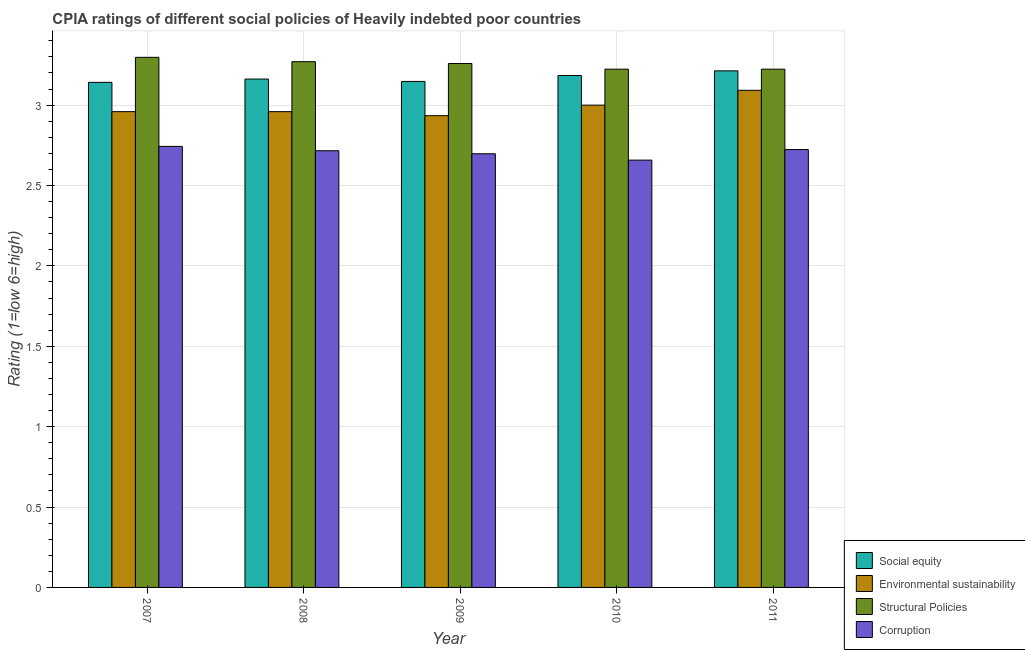Are the number of bars per tick equal to the number of legend labels?
Ensure brevity in your answer.  Yes. Are the number of bars on each tick of the X-axis equal?
Give a very brief answer. Yes. How many bars are there on the 1st tick from the right?
Offer a very short reply. 4. What is the cpia rating of corruption in 2008?
Ensure brevity in your answer.  2.72. Across all years, what is the maximum cpia rating of corruption?
Offer a terse response. 2.74. Across all years, what is the minimum cpia rating of social equity?
Provide a short and direct response. 3.14. In which year was the cpia rating of corruption maximum?
Your answer should be very brief. 2007. In which year was the cpia rating of corruption minimum?
Provide a succinct answer. 2010. What is the total cpia rating of structural policies in the graph?
Provide a succinct answer. 16.27. What is the difference between the cpia rating of environmental sustainability in 2007 and that in 2011?
Your answer should be compact. -0.13. What is the difference between the cpia rating of social equity in 2010 and the cpia rating of corruption in 2011?
Provide a short and direct response. -0.03. What is the average cpia rating of social equity per year?
Give a very brief answer. 3.17. In the year 2007, what is the difference between the cpia rating of social equity and cpia rating of structural policies?
Ensure brevity in your answer.  0. In how many years, is the cpia rating of environmental sustainability greater than 0.6?
Provide a short and direct response. 5. What is the ratio of the cpia rating of corruption in 2009 to that in 2010?
Your answer should be compact. 1.01. Is the cpia rating of environmental sustainability in 2007 less than that in 2009?
Ensure brevity in your answer.  No. Is the difference between the cpia rating of environmental sustainability in 2007 and 2011 greater than the difference between the cpia rating of corruption in 2007 and 2011?
Offer a terse response. No. What is the difference between the highest and the second highest cpia rating of environmental sustainability?
Make the answer very short. 0.09. What is the difference between the highest and the lowest cpia rating of structural policies?
Offer a terse response. 0.07. In how many years, is the cpia rating of structural policies greater than the average cpia rating of structural policies taken over all years?
Your answer should be compact. 3. Is the sum of the cpia rating of corruption in 2007 and 2010 greater than the maximum cpia rating of environmental sustainability across all years?
Provide a short and direct response. Yes. What does the 2nd bar from the left in 2008 represents?
Ensure brevity in your answer.  Environmental sustainability. What does the 3rd bar from the right in 2007 represents?
Keep it short and to the point. Environmental sustainability. Is it the case that in every year, the sum of the cpia rating of social equity and cpia rating of environmental sustainability is greater than the cpia rating of structural policies?
Make the answer very short. Yes. How many bars are there?
Keep it short and to the point. 20. What is the difference between two consecutive major ticks on the Y-axis?
Your answer should be very brief. 0.5. Are the values on the major ticks of Y-axis written in scientific E-notation?
Offer a very short reply. No. Does the graph contain any zero values?
Ensure brevity in your answer.  No. Does the graph contain grids?
Offer a terse response. Yes. How many legend labels are there?
Offer a very short reply. 4. What is the title of the graph?
Provide a short and direct response. CPIA ratings of different social policies of Heavily indebted poor countries. Does "Public sector management" appear as one of the legend labels in the graph?
Ensure brevity in your answer.  No. What is the label or title of the Y-axis?
Your answer should be very brief. Rating (1=low 6=high). What is the Rating (1=low 6=high) of Social equity in 2007?
Ensure brevity in your answer.  3.14. What is the Rating (1=low 6=high) in Environmental sustainability in 2007?
Give a very brief answer. 2.96. What is the Rating (1=low 6=high) in Structural Policies in 2007?
Keep it short and to the point. 3.3. What is the Rating (1=low 6=high) in Corruption in 2007?
Give a very brief answer. 2.74. What is the Rating (1=low 6=high) of Social equity in 2008?
Give a very brief answer. 3.16. What is the Rating (1=low 6=high) in Environmental sustainability in 2008?
Your answer should be compact. 2.96. What is the Rating (1=low 6=high) of Structural Policies in 2008?
Provide a succinct answer. 3.27. What is the Rating (1=low 6=high) in Corruption in 2008?
Make the answer very short. 2.72. What is the Rating (1=low 6=high) in Social equity in 2009?
Provide a short and direct response. 3.15. What is the Rating (1=low 6=high) of Environmental sustainability in 2009?
Your response must be concise. 2.93. What is the Rating (1=low 6=high) of Structural Policies in 2009?
Provide a short and direct response. 3.26. What is the Rating (1=low 6=high) of Corruption in 2009?
Your response must be concise. 2.7. What is the Rating (1=low 6=high) of Social equity in 2010?
Make the answer very short. 3.18. What is the Rating (1=low 6=high) in Environmental sustainability in 2010?
Offer a very short reply. 3. What is the Rating (1=low 6=high) in Structural Policies in 2010?
Offer a very short reply. 3.22. What is the Rating (1=low 6=high) of Corruption in 2010?
Ensure brevity in your answer.  2.66. What is the Rating (1=low 6=high) of Social equity in 2011?
Make the answer very short. 3.21. What is the Rating (1=low 6=high) in Environmental sustainability in 2011?
Give a very brief answer. 3.09. What is the Rating (1=low 6=high) in Structural Policies in 2011?
Your answer should be very brief. 3.22. What is the Rating (1=low 6=high) of Corruption in 2011?
Offer a very short reply. 2.72. Across all years, what is the maximum Rating (1=low 6=high) in Social equity?
Keep it short and to the point. 3.21. Across all years, what is the maximum Rating (1=low 6=high) in Environmental sustainability?
Make the answer very short. 3.09. Across all years, what is the maximum Rating (1=low 6=high) in Structural Policies?
Make the answer very short. 3.3. Across all years, what is the maximum Rating (1=low 6=high) in Corruption?
Give a very brief answer. 2.74. Across all years, what is the minimum Rating (1=low 6=high) of Social equity?
Offer a very short reply. 3.14. Across all years, what is the minimum Rating (1=low 6=high) in Environmental sustainability?
Provide a succinct answer. 2.93. Across all years, what is the minimum Rating (1=low 6=high) of Structural Policies?
Keep it short and to the point. 3.22. Across all years, what is the minimum Rating (1=low 6=high) in Corruption?
Offer a terse response. 2.66. What is the total Rating (1=low 6=high) in Social equity in the graph?
Give a very brief answer. 15.85. What is the total Rating (1=low 6=high) of Environmental sustainability in the graph?
Offer a very short reply. 14.95. What is the total Rating (1=low 6=high) in Structural Policies in the graph?
Keep it short and to the point. 16.27. What is the total Rating (1=low 6=high) of Corruption in the graph?
Make the answer very short. 13.54. What is the difference between the Rating (1=low 6=high) in Social equity in 2007 and that in 2008?
Provide a succinct answer. -0.02. What is the difference between the Rating (1=low 6=high) in Environmental sustainability in 2007 and that in 2008?
Your answer should be compact. 0. What is the difference between the Rating (1=low 6=high) of Structural Policies in 2007 and that in 2008?
Your answer should be compact. 0.03. What is the difference between the Rating (1=low 6=high) in Corruption in 2007 and that in 2008?
Provide a succinct answer. 0.03. What is the difference between the Rating (1=low 6=high) in Social equity in 2007 and that in 2009?
Your answer should be very brief. -0.01. What is the difference between the Rating (1=low 6=high) in Environmental sustainability in 2007 and that in 2009?
Keep it short and to the point. 0.03. What is the difference between the Rating (1=low 6=high) in Structural Policies in 2007 and that in 2009?
Give a very brief answer. 0.04. What is the difference between the Rating (1=low 6=high) in Corruption in 2007 and that in 2009?
Your answer should be very brief. 0.05. What is the difference between the Rating (1=low 6=high) of Social equity in 2007 and that in 2010?
Provide a succinct answer. -0.04. What is the difference between the Rating (1=low 6=high) of Environmental sustainability in 2007 and that in 2010?
Keep it short and to the point. -0.04. What is the difference between the Rating (1=low 6=high) of Structural Policies in 2007 and that in 2010?
Your answer should be very brief. 0.07. What is the difference between the Rating (1=low 6=high) in Corruption in 2007 and that in 2010?
Give a very brief answer. 0.09. What is the difference between the Rating (1=low 6=high) of Social equity in 2007 and that in 2011?
Your response must be concise. -0.07. What is the difference between the Rating (1=low 6=high) in Environmental sustainability in 2007 and that in 2011?
Make the answer very short. -0.13. What is the difference between the Rating (1=low 6=high) of Structural Policies in 2007 and that in 2011?
Offer a terse response. 0.07. What is the difference between the Rating (1=low 6=high) of Corruption in 2007 and that in 2011?
Offer a very short reply. 0.02. What is the difference between the Rating (1=low 6=high) in Social equity in 2008 and that in 2009?
Offer a very short reply. 0.01. What is the difference between the Rating (1=low 6=high) of Environmental sustainability in 2008 and that in 2009?
Keep it short and to the point. 0.03. What is the difference between the Rating (1=low 6=high) of Structural Policies in 2008 and that in 2009?
Provide a short and direct response. 0.01. What is the difference between the Rating (1=low 6=high) in Corruption in 2008 and that in 2009?
Ensure brevity in your answer.  0.02. What is the difference between the Rating (1=low 6=high) in Social equity in 2008 and that in 2010?
Your answer should be very brief. -0.02. What is the difference between the Rating (1=low 6=high) of Environmental sustainability in 2008 and that in 2010?
Keep it short and to the point. -0.04. What is the difference between the Rating (1=low 6=high) of Structural Policies in 2008 and that in 2010?
Provide a succinct answer. 0.05. What is the difference between the Rating (1=low 6=high) of Corruption in 2008 and that in 2010?
Provide a succinct answer. 0.06. What is the difference between the Rating (1=low 6=high) of Social equity in 2008 and that in 2011?
Your answer should be compact. -0.05. What is the difference between the Rating (1=low 6=high) in Environmental sustainability in 2008 and that in 2011?
Your answer should be compact. -0.13. What is the difference between the Rating (1=low 6=high) in Structural Policies in 2008 and that in 2011?
Provide a succinct answer. 0.05. What is the difference between the Rating (1=low 6=high) of Corruption in 2008 and that in 2011?
Keep it short and to the point. -0.01. What is the difference between the Rating (1=low 6=high) in Social equity in 2009 and that in 2010?
Ensure brevity in your answer.  -0.04. What is the difference between the Rating (1=low 6=high) in Environmental sustainability in 2009 and that in 2010?
Make the answer very short. -0.07. What is the difference between the Rating (1=low 6=high) of Structural Policies in 2009 and that in 2010?
Offer a very short reply. 0.04. What is the difference between the Rating (1=low 6=high) in Corruption in 2009 and that in 2010?
Your answer should be compact. 0.04. What is the difference between the Rating (1=low 6=high) in Social equity in 2009 and that in 2011?
Provide a succinct answer. -0.07. What is the difference between the Rating (1=low 6=high) in Environmental sustainability in 2009 and that in 2011?
Your response must be concise. -0.16. What is the difference between the Rating (1=low 6=high) of Structural Policies in 2009 and that in 2011?
Offer a very short reply. 0.04. What is the difference between the Rating (1=low 6=high) of Corruption in 2009 and that in 2011?
Keep it short and to the point. -0.03. What is the difference between the Rating (1=low 6=high) of Social equity in 2010 and that in 2011?
Your response must be concise. -0.03. What is the difference between the Rating (1=low 6=high) of Environmental sustainability in 2010 and that in 2011?
Provide a succinct answer. -0.09. What is the difference between the Rating (1=low 6=high) in Corruption in 2010 and that in 2011?
Provide a short and direct response. -0.07. What is the difference between the Rating (1=low 6=high) of Social equity in 2007 and the Rating (1=low 6=high) of Environmental sustainability in 2008?
Give a very brief answer. 0.18. What is the difference between the Rating (1=low 6=high) in Social equity in 2007 and the Rating (1=low 6=high) in Structural Policies in 2008?
Ensure brevity in your answer.  -0.13. What is the difference between the Rating (1=low 6=high) of Social equity in 2007 and the Rating (1=low 6=high) of Corruption in 2008?
Provide a succinct answer. 0.43. What is the difference between the Rating (1=low 6=high) of Environmental sustainability in 2007 and the Rating (1=low 6=high) of Structural Policies in 2008?
Your answer should be very brief. -0.31. What is the difference between the Rating (1=low 6=high) in Environmental sustainability in 2007 and the Rating (1=low 6=high) in Corruption in 2008?
Your answer should be very brief. 0.24. What is the difference between the Rating (1=low 6=high) of Structural Policies in 2007 and the Rating (1=low 6=high) of Corruption in 2008?
Keep it short and to the point. 0.58. What is the difference between the Rating (1=low 6=high) in Social equity in 2007 and the Rating (1=low 6=high) in Environmental sustainability in 2009?
Offer a very short reply. 0.21. What is the difference between the Rating (1=low 6=high) in Social equity in 2007 and the Rating (1=low 6=high) in Structural Policies in 2009?
Give a very brief answer. -0.12. What is the difference between the Rating (1=low 6=high) in Social equity in 2007 and the Rating (1=low 6=high) in Corruption in 2009?
Your response must be concise. 0.44. What is the difference between the Rating (1=low 6=high) of Environmental sustainability in 2007 and the Rating (1=low 6=high) of Structural Policies in 2009?
Make the answer very short. -0.3. What is the difference between the Rating (1=low 6=high) of Environmental sustainability in 2007 and the Rating (1=low 6=high) of Corruption in 2009?
Provide a short and direct response. 0.26. What is the difference between the Rating (1=low 6=high) of Structural Policies in 2007 and the Rating (1=low 6=high) of Corruption in 2009?
Give a very brief answer. 0.6. What is the difference between the Rating (1=low 6=high) in Social equity in 2007 and the Rating (1=low 6=high) in Environmental sustainability in 2010?
Ensure brevity in your answer.  0.14. What is the difference between the Rating (1=low 6=high) in Social equity in 2007 and the Rating (1=low 6=high) in Structural Policies in 2010?
Make the answer very short. -0.08. What is the difference between the Rating (1=low 6=high) in Social equity in 2007 and the Rating (1=low 6=high) in Corruption in 2010?
Keep it short and to the point. 0.48. What is the difference between the Rating (1=low 6=high) of Environmental sustainability in 2007 and the Rating (1=low 6=high) of Structural Policies in 2010?
Ensure brevity in your answer.  -0.26. What is the difference between the Rating (1=low 6=high) in Environmental sustainability in 2007 and the Rating (1=low 6=high) in Corruption in 2010?
Your response must be concise. 0.3. What is the difference between the Rating (1=low 6=high) of Structural Policies in 2007 and the Rating (1=low 6=high) of Corruption in 2010?
Ensure brevity in your answer.  0.64. What is the difference between the Rating (1=low 6=high) of Social equity in 2007 and the Rating (1=low 6=high) of Environmental sustainability in 2011?
Provide a short and direct response. 0.05. What is the difference between the Rating (1=low 6=high) in Social equity in 2007 and the Rating (1=low 6=high) in Structural Policies in 2011?
Provide a succinct answer. -0.08. What is the difference between the Rating (1=low 6=high) in Social equity in 2007 and the Rating (1=low 6=high) in Corruption in 2011?
Provide a short and direct response. 0.42. What is the difference between the Rating (1=low 6=high) in Environmental sustainability in 2007 and the Rating (1=low 6=high) in Structural Policies in 2011?
Give a very brief answer. -0.26. What is the difference between the Rating (1=low 6=high) of Environmental sustainability in 2007 and the Rating (1=low 6=high) of Corruption in 2011?
Your answer should be compact. 0.24. What is the difference between the Rating (1=low 6=high) in Structural Policies in 2007 and the Rating (1=low 6=high) in Corruption in 2011?
Keep it short and to the point. 0.57. What is the difference between the Rating (1=low 6=high) of Social equity in 2008 and the Rating (1=low 6=high) of Environmental sustainability in 2009?
Make the answer very short. 0.23. What is the difference between the Rating (1=low 6=high) of Social equity in 2008 and the Rating (1=low 6=high) of Structural Policies in 2009?
Offer a terse response. -0.1. What is the difference between the Rating (1=low 6=high) in Social equity in 2008 and the Rating (1=low 6=high) in Corruption in 2009?
Make the answer very short. 0.46. What is the difference between the Rating (1=low 6=high) of Environmental sustainability in 2008 and the Rating (1=low 6=high) of Structural Policies in 2009?
Offer a terse response. -0.3. What is the difference between the Rating (1=low 6=high) in Environmental sustainability in 2008 and the Rating (1=low 6=high) in Corruption in 2009?
Provide a short and direct response. 0.26. What is the difference between the Rating (1=low 6=high) of Structural Policies in 2008 and the Rating (1=low 6=high) of Corruption in 2009?
Make the answer very short. 0.57. What is the difference between the Rating (1=low 6=high) of Social equity in 2008 and the Rating (1=low 6=high) of Environmental sustainability in 2010?
Provide a short and direct response. 0.16. What is the difference between the Rating (1=low 6=high) in Social equity in 2008 and the Rating (1=low 6=high) in Structural Policies in 2010?
Offer a very short reply. -0.06. What is the difference between the Rating (1=low 6=high) of Social equity in 2008 and the Rating (1=low 6=high) of Corruption in 2010?
Offer a very short reply. 0.5. What is the difference between the Rating (1=low 6=high) in Environmental sustainability in 2008 and the Rating (1=low 6=high) in Structural Policies in 2010?
Your response must be concise. -0.26. What is the difference between the Rating (1=low 6=high) of Environmental sustainability in 2008 and the Rating (1=low 6=high) of Corruption in 2010?
Your response must be concise. 0.3. What is the difference between the Rating (1=low 6=high) in Structural Policies in 2008 and the Rating (1=low 6=high) in Corruption in 2010?
Offer a terse response. 0.61. What is the difference between the Rating (1=low 6=high) of Social equity in 2008 and the Rating (1=low 6=high) of Environmental sustainability in 2011?
Make the answer very short. 0.07. What is the difference between the Rating (1=low 6=high) of Social equity in 2008 and the Rating (1=low 6=high) of Structural Policies in 2011?
Make the answer very short. -0.06. What is the difference between the Rating (1=low 6=high) of Social equity in 2008 and the Rating (1=low 6=high) of Corruption in 2011?
Provide a succinct answer. 0.44. What is the difference between the Rating (1=low 6=high) of Environmental sustainability in 2008 and the Rating (1=low 6=high) of Structural Policies in 2011?
Keep it short and to the point. -0.26. What is the difference between the Rating (1=low 6=high) of Environmental sustainability in 2008 and the Rating (1=low 6=high) of Corruption in 2011?
Keep it short and to the point. 0.24. What is the difference between the Rating (1=low 6=high) in Structural Policies in 2008 and the Rating (1=low 6=high) in Corruption in 2011?
Keep it short and to the point. 0.55. What is the difference between the Rating (1=low 6=high) in Social equity in 2009 and the Rating (1=low 6=high) in Environmental sustainability in 2010?
Your response must be concise. 0.15. What is the difference between the Rating (1=low 6=high) of Social equity in 2009 and the Rating (1=low 6=high) of Structural Policies in 2010?
Offer a very short reply. -0.08. What is the difference between the Rating (1=low 6=high) in Social equity in 2009 and the Rating (1=low 6=high) in Corruption in 2010?
Provide a short and direct response. 0.49. What is the difference between the Rating (1=low 6=high) in Environmental sustainability in 2009 and the Rating (1=low 6=high) in Structural Policies in 2010?
Keep it short and to the point. -0.29. What is the difference between the Rating (1=low 6=high) of Environmental sustainability in 2009 and the Rating (1=low 6=high) of Corruption in 2010?
Make the answer very short. 0.28. What is the difference between the Rating (1=low 6=high) of Structural Policies in 2009 and the Rating (1=low 6=high) of Corruption in 2010?
Your answer should be very brief. 0.6. What is the difference between the Rating (1=low 6=high) of Social equity in 2009 and the Rating (1=low 6=high) of Environmental sustainability in 2011?
Offer a very short reply. 0.06. What is the difference between the Rating (1=low 6=high) of Social equity in 2009 and the Rating (1=low 6=high) of Structural Policies in 2011?
Make the answer very short. -0.08. What is the difference between the Rating (1=low 6=high) of Social equity in 2009 and the Rating (1=low 6=high) of Corruption in 2011?
Offer a terse response. 0.42. What is the difference between the Rating (1=low 6=high) in Environmental sustainability in 2009 and the Rating (1=low 6=high) in Structural Policies in 2011?
Offer a terse response. -0.29. What is the difference between the Rating (1=low 6=high) of Environmental sustainability in 2009 and the Rating (1=low 6=high) of Corruption in 2011?
Your answer should be very brief. 0.21. What is the difference between the Rating (1=low 6=high) of Structural Policies in 2009 and the Rating (1=low 6=high) of Corruption in 2011?
Keep it short and to the point. 0.54. What is the difference between the Rating (1=low 6=high) in Social equity in 2010 and the Rating (1=low 6=high) in Environmental sustainability in 2011?
Your answer should be compact. 0.09. What is the difference between the Rating (1=low 6=high) of Social equity in 2010 and the Rating (1=low 6=high) of Structural Policies in 2011?
Keep it short and to the point. -0.04. What is the difference between the Rating (1=low 6=high) in Social equity in 2010 and the Rating (1=low 6=high) in Corruption in 2011?
Offer a very short reply. 0.46. What is the difference between the Rating (1=low 6=high) of Environmental sustainability in 2010 and the Rating (1=low 6=high) of Structural Policies in 2011?
Give a very brief answer. -0.22. What is the difference between the Rating (1=low 6=high) in Environmental sustainability in 2010 and the Rating (1=low 6=high) in Corruption in 2011?
Make the answer very short. 0.28. What is the difference between the Rating (1=low 6=high) of Structural Policies in 2010 and the Rating (1=low 6=high) of Corruption in 2011?
Provide a succinct answer. 0.5. What is the average Rating (1=low 6=high) of Social equity per year?
Offer a very short reply. 3.17. What is the average Rating (1=low 6=high) of Environmental sustainability per year?
Keep it short and to the point. 2.99. What is the average Rating (1=low 6=high) of Structural Policies per year?
Keep it short and to the point. 3.25. What is the average Rating (1=low 6=high) of Corruption per year?
Keep it short and to the point. 2.71. In the year 2007, what is the difference between the Rating (1=low 6=high) in Social equity and Rating (1=low 6=high) in Environmental sustainability?
Make the answer very short. 0.18. In the year 2007, what is the difference between the Rating (1=low 6=high) in Social equity and Rating (1=low 6=high) in Structural Policies?
Your response must be concise. -0.16. In the year 2007, what is the difference between the Rating (1=low 6=high) in Social equity and Rating (1=low 6=high) in Corruption?
Your response must be concise. 0.4. In the year 2007, what is the difference between the Rating (1=low 6=high) of Environmental sustainability and Rating (1=low 6=high) of Structural Policies?
Your answer should be compact. -0.34. In the year 2007, what is the difference between the Rating (1=low 6=high) in Environmental sustainability and Rating (1=low 6=high) in Corruption?
Keep it short and to the point. 0.22. In the year 2007, what is the difference between the Rating (1=low 6=high) of Structural Policies and Rating (1=low 6=high) of Corruption?
Offer a very short reply. 0.55. In the year 2008, what is the difference between the Rating (1=low 6=high) in Social equity and Rating (1=low 6=high) in Environmental sustainability?
Give a very brief answer. 0.2. In the year 2008, what is the difference between the Rating (1=low 6=high) of Social equity and Rating (1=low 6=high) of Structural Policies?
Ensure brevity in your answer.  -0.11. In the year 2008, what is the difference between the Rating (1=low 6=high) in Social equity and Rating (1=low 6=high) in Corruption?
Give a very brief answer. 0.45. In the year 2008, what is the difference between the Rating (1=low 6=high) of Environmental sustainability and Rating (1=low 6=high) of Structural Policies?
Your answer should be very brief. -0.31. In the year 2008, what is the difference between the Rating (1=low 6=high) in Environmental sustainability and Rating (1=low 6=high) in Corruption?
Your answer should be very brief. 0.24. In the year 2008, what is the difference between the Rating (1=low 6=high) of Structural Policies and Rating (1=low 6=high) of Corruption?
Offer a very short reply. 0.55. In the year 2009, what is the difference between the Rating (1=low 6=high) of Social equity and Rating (1=low 6=high) of Environmental sustainability?
Give a very brief answer. 0.21. In the year 2009, what is the difference between the Rating (1=low 6=high) of Social equity and Rating (1=low 6=high) of Structural Policies?
Offer a very short reply. -0.11. In the year 2009, what is the difference between the Rating (1=low 6=high) in Social equity and Rating (1=low 6=high) in Corruption?
Keep it short and to the point. 0.45. In the year 2009, what is the difference between the Rating (1=low 6=high) in Environmental sustainability and Rating (1=low 6=high) in Structural Policies?
Give a very brief answer. -0.32. In the year 2009, what is the difference between the Rating (1=low 6=high) in Environmental sustainability and Rating (1=low 6=high) in Corruption?
Your answer should be compact. 0.24. In the year 2009, what is the difference between the Rating (1=low 6=high) in Structural Policies and Rating (1=low 6=high) in Corruption?
Keep it short and to the point. 0.56. In the year 2010, what is the difference between the Rating (1=low 6=high) of Social equity and Rating (1=low 6=high) of Environmental sustainability?
Ensure brevity in your answer.  0.18. In the year 2010, what is the difference between the Rating (1=low 6=high) in Social equity and Rating (1=low 6=high) in Structural Policies?
Ensure brevity in your answer.  -0.04. In the year 2010, what is the difference between the Rating (1=low 6=high) of Social equity and Rating (1=low 6=high) of Corruption?
Offer a very short reply. 0.53. In the year 2010, what is the difference between the Rating (1=low 6=high) in Environmental sustainability and Rating (1=low 6=high) in Structural Policies?
Give a very brief answer. -0.22. In the year 2010, what is the difference between the Rating (1=low 6=high) in Environmental sustainability and Rating (1=low 6=high) in Corruption?
Provide a succinct answer. 0.34. In the year 2010, what is the difference between the Rating (1=low 6=high) in Structural Policies and Rating (1=low 6=high) in Corruption?
Keep it short and to the point. 0.57. In the year 2011, what is the difference between the Rating (1=low 6=high) of Social equity and Rating (1=low 6=high) of Environmental sustainability?
Provide a short and direct response. 0.12. In the year 2011, what is the difference between the Rating (1=low 6=high) in Social equity and Rating (1=low 6=high) in Structural Policies?
Provide a succinct answer. -0.01. In the year 2011, what is the difference between the Rating (1=low 6=high) of Social equity and Rating (1=low 6=high) of Corruption?
Keep it short and to the point. 0.49. In the year 2011, what is the difference between the Rating (1=low 6=high) in Environmental sustainability and Rating (1=low 6=high) in Structural Policies?
Offer a very short reply. -0.13. In the year 2011, what is the difference between the Rating (1=low 6=high) in Environmental sustainability and Rating (1=low 6=high) in Corruption?
Your response must be concise. 0.37. In the year 2011, what is the difference between the Rating (1=low 6=high) in Structural Policies and Rating (1=low 6=high) in Corruption?
Ensure brevity in your answer.  0.5. What is the ratio of the Rating (1=low 6=high) of Social equity in 2007 to that in 2008?
Ensure brevity in your answer.  0.99. What is the ratio of the Rating (1=low 6=high) in Structural Policies in 2007 to that in 2008?
Provide a short and direct response. 1.01. What is the ratio of the Rating (1=low 6=high) in Corruption in 2007 to that in 2008?
Offer a very short reply. 1.01. What is the ratio of the Rating (1=low 6=high) of Social equity in 2007 to that in 2009?
Your answer should be very brief. 1. What is the ratio of the Rating (1=low 6=high) of Environmental sustainability in 2007 to that in 2009?
Provide a short and direct response. 1.01. What is the ratio of the Rating (1=low 6=high) of Structural Policies in 2007 to that in 2009?
Offer a very short reply. 1.01. What is the ratio of the Rating (1=low 6=high) of Social equity in 2007 to that in 2010?
Your answer should be very brief. 0.99. What is the ratio of the Rating (1=low 6=high) in Environmental sustainability in 2007 to that in 2010?
Your answer should be compact. 0.99. What is the ratio of the Rating (1=low 6=high) in Structural Policies in 2007 to that in 2010?
Your response must be concise. 1.02. What is the ratio of the Rating (1=low 6=high) of Corruption in 2007 to that in 2010?
Offer a very short reply. 1.03. What is the ratio of the Rating (1=low 6=high) of Social equity in 2007 to that in 2011?
Offer a terse response. 0.98. What is the ratio of the Rating (1=low 6=high) of Environmental sustainability in 2007 to that in 2011?
Provide a succinct answer. 0.96. What is the ratio of the Rating (1=low 6=high) in Structural Policies in 2007 to that in 2011?
Make the answer very short. 1.02. What is the ratio of the Rating (1=low 6=high) in Social equity in 2008 to that in 2009?
Make the answer very short. 1. What is the ratio of the Rating (1=low 6=high) in Environmental sustainability in 2008 to that in 2009?
Your response must be concise. 1.01. What is the ratio of the Rating (1=low 6=high) of Corruption in 2008 to that in 2009?
Your answer should be compact. 1.01. What is the ratio of the Rating (1=low 6=high) of Environmental sustainability in 2008 to that in 2010?
Keep it short and to the point. 0.99. What is the ratio of the Rating (1=low 6=high) in Structural Policies in 2008 to that in 2010?
Offer a terse response. 1.01. What is the ratio of the Rating (1=low 6=high) in Corruption in 2008 to that in 2010?
Offer a terse response. 1.02. What is the ratio of the Rating (1=low 6=high) of Social equity in 2008 to that in 2011?
Provide a succinct answer. 0.98. What is the ratio of the Rating (1=low 6=high) in Environmental sustainability in 2008 to that in 2011?
Provide a short and direct response. 0.96. What is the ratio of the Rating (1=low 6=high) in Structural Policies in 2008 to that in 2011?
Give a very brief answer. 1.01. What is the ratio of the Rating (1=low 6=high) of Corruption in 2008 to that in 2011?
Keep it short and to the point. 1. What is the ratio of the Rating (1=low 6=high) of Social equity in 2009 to that in 2010?
Your response must be concise. 0.99. What is the ratio of the Rating (1=low 6=high) in Environmental sustainability in 2009 to that in 2010?
Provide a succinct answer. 0.98. What is the ratio of the Rating (1=low 6=high) in Structural Policies in 2009 to that in 2010?
Provide a short and direct response. 1.01. What is the ratio of the Rating (1=low 6=high) of Corruption in 2009 to that in 2010?
Offer a very short reply. 1.01. What is the ratio of the Rating (1=low 6=high) of Social equity in 2009 to that in 2011?
Offer a terse response. 0.98. What is the ratio of the Rating (1=low 6=high) of Environmental sustainability in 2009 to that in 2011?
Keep it short and to the point. 0.95. What is the ratio of the Rating (1=low 6=high) of Structural Policies in 2009 to that in 2011?
Give a very brief answer. 1.01. What is the ratio of the Rating (1=low 6=high) of Corruption in 2009 to that in 2011?
Provide a succinct answer. 0.99. What is the ratio of the Rating (1=low 6=high) in Social equity in 2010 to that in 2011?
Your response must be concise. 0.99. What is the ratio of the Rating (1=low 6=high) of Environmental sustainability in 2010 to that in 2011?
Offer a very short reply. 0.97. What is the ratio of the Rating (1=low 6=high) in Structural Policies in 2010 to that in 2011?
Provide a short and direct response. 1. What is the ratio of the Rating (1=low 6=high) in Corruption in 2010 to that in 2011?
Give a very brief answer. 0.98. What is the difference between the highest and the second highest Rating (1=low 6=high) in Social equity?
Give a very brief answer. 0.03. What is the difference between the highest and the second highest Rating (1=low 6=high) in Environmental sustainability?
Your answer should be compact. 0.09. What is the difference between the highest and the second highest Rating (1=low 6=high) in Structural Policies?
Ensure brevity in your answer.  0.03. What is the difference between the highest and the second highest Rating (1=low 6=high) of Corruption?
Your answer should be compact. 0.02. What is the difference between the highest and the lowest Rating (1=low 6=high) in Social equity?
Your response must be concise. 0.07. What is the difference between the highest and the lowest Rating (1=low 6=high) of Environmental sustainability?
Keep it short and to the point. 0.16. What is the difference between the highest and the lowest Rating (1=low 6=high) of Structural Policies?
Ensure brevity in your answer.  0.07. What is the difference between the highest and the lowest Rating (1=low 6=high) of Corruption?
Offer a terse response. 0.09. 